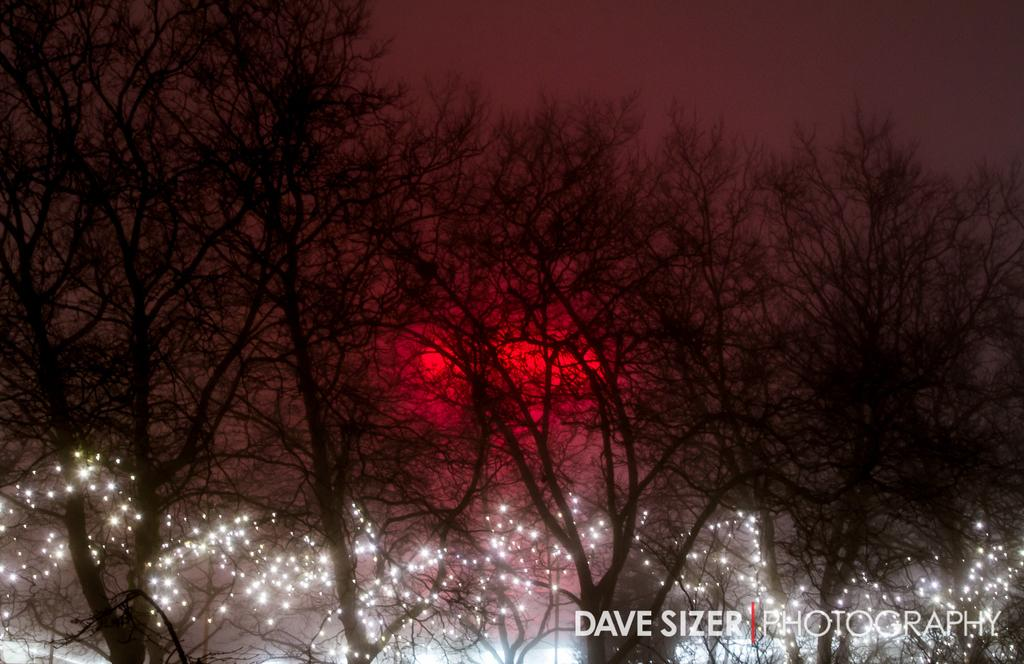What type of vegetation is present in the image? There are dry trees in the image. What else can be seen in the image besides the trees? There are lights visible in the image. Can you describe the color scheme of the background in the image? The background of the image has red, black, and grey colors. How many cannons are present in the image? There are no cannons present in the image. What types of things can be seen in the image? The image features dry trees and lights, as mentioned in the conversation. However, the question is too vague and cannot be answered definitively. 